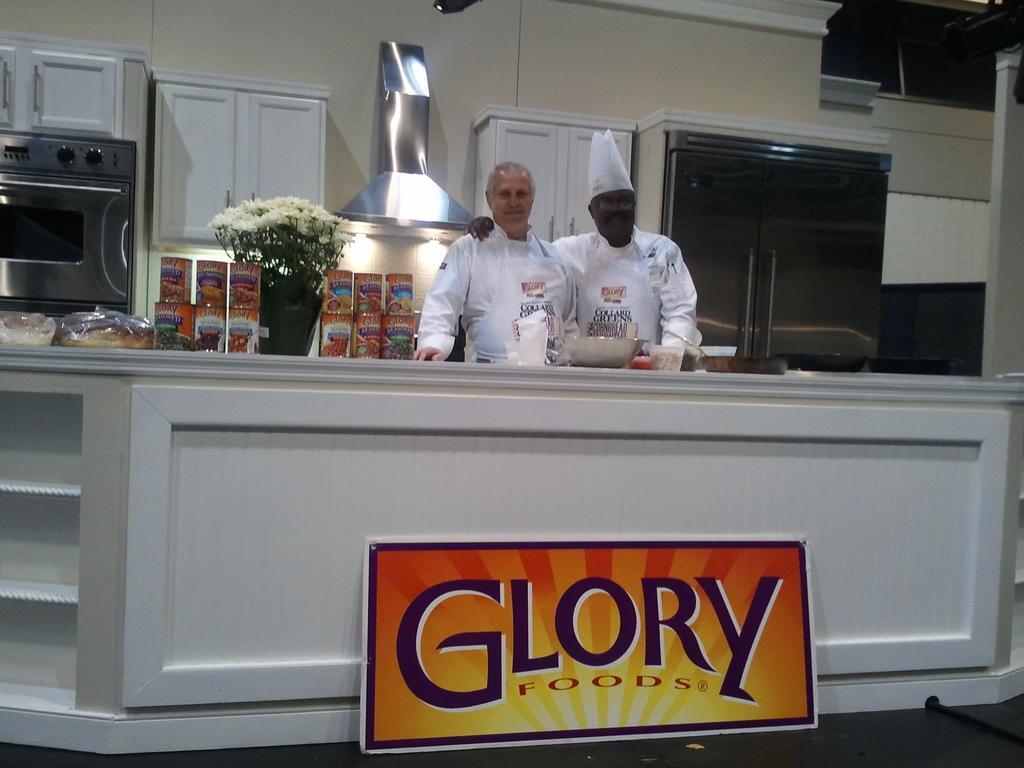Please provide a concise description of this image. In this image there is a counter on that counter there is some text, behind the counter there are two chefs, on that counter there are food items and pot, in the background there is micro oven and shelves. 